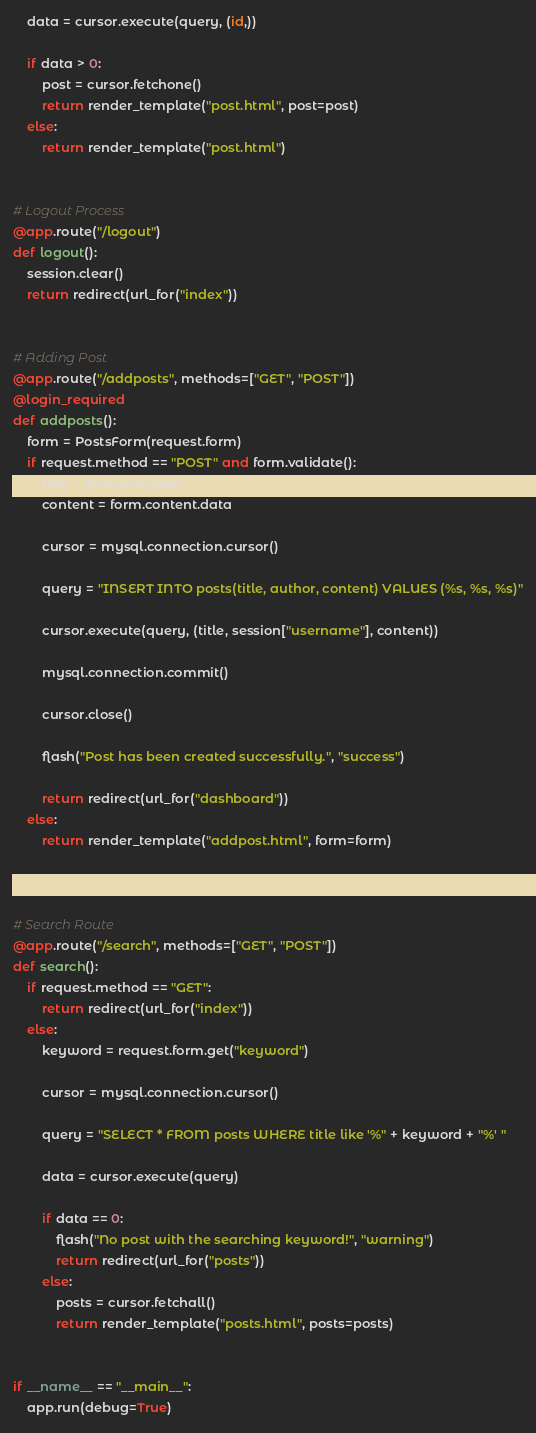<code> <loc_0><loc_0><loc_500><loc_500><_Python_>
    data = cursor.execute(query, (id,))

    if data > 0:
        post = cursor.fetchone()
        return render_template("post.html", post=post)
    else:
        return render_template("post.html")


# Logout Process
@app.route("/logout")
def logout():
    session.clear()
    return redirect(url_for("index"))


# Adding Post
@app.route("/addposts", methods=["GET", "POST"])
@login_required
def addposts():
    form = PostsForm(request.form)
    if request.method == "POST" and form.validate():
        title = form.title.data
        content = form.content.data

        cursor = mysql.connection.cursor()

        query = "INSERT INTO posts(title, author, content) VALUES (%s, %s, %s)"

        cursor.execute(query, (title, session["username"], content))

        mysql.connection.commit()

        cursor.close()

        flash("Post has been created successfully.", "success")

        return redirect(url_for("dashboard"))
    else:
        return render_template("addpost.html", form=form)



# Search Route
@app.route("/search", methods=["GET", "POST"])
def search():
    if request.method == "GET":
        return redirect(url_for("index"))
    else:
        keyword = request.form.get("keyword")

        cursor = mysql.connection.cursor()

        query = "SELECT * FROM posts WHERE title like '%" + keyword + "%' "

        data = cursor.execute(query)

        if data == 0:
            flash("No post with the searching keyword!", "warning")
            return redirect(url_for("posts"))
        else:
            posts = cursor.fetchall()
            return render_template("posts.html", posts=posts)


if __name__ == "__main__":
    app.run(debug=True)
</code> 